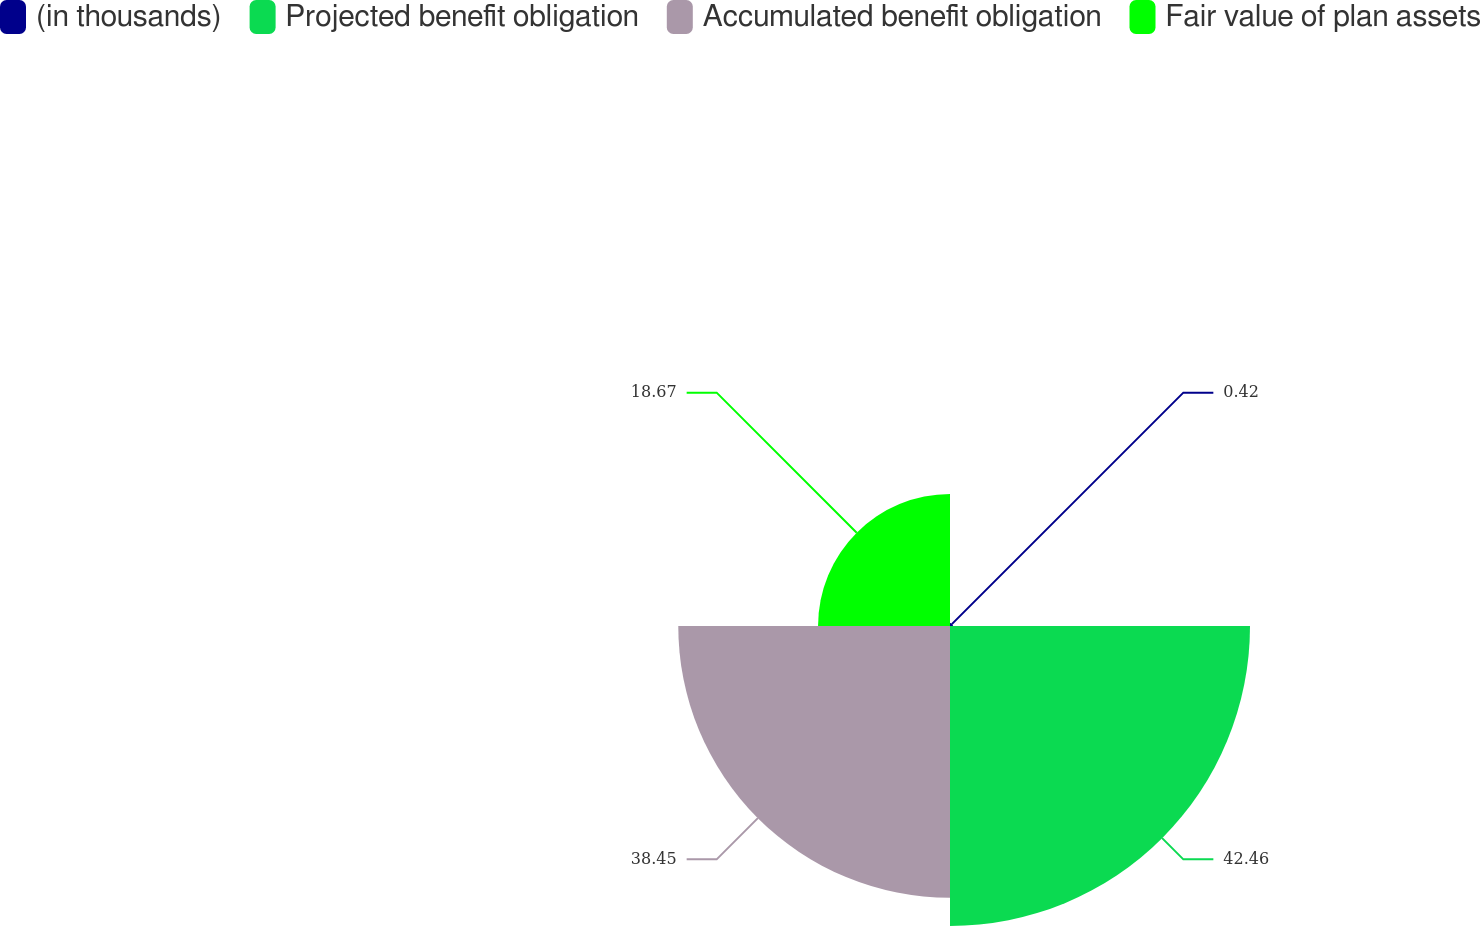Convert chart to OTSL. <chart><loc_0><loc_0><loc_500><loc_500><pie_chart><fcel>(in thousands)<fcel>Projected benefit obligation<fcel>Accumulated benefit obligation<fcel>Fair value of plan assets<nl><fcel>0.42%<fcel>42.45%<fcel>38.45%<fcel>18.67%<nl></chart> 